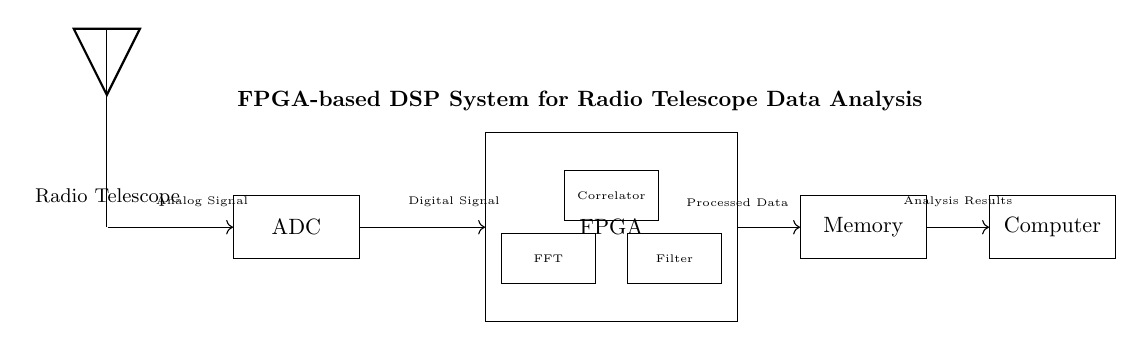What is the first component in the circuit? The first component is the Radio Telescope, which is indicated on the left side of the diagram.
Answer: Radio Telescope What does the ADC convert? The ADC converts the analog signal received from the radio telescope into a digital signal for further processing.
Answer: Analog Signal How many DSP blocks are inside the FPGA? There are three DSP blocks inside the FPGA: FFT, Filter, and Correlator.
Answer: Three What type of system is depicted in this diagram? The diagram represents an FPGA-based digital signal processing system, as stated in the title at the top of the diagram.
Answer: FPGA-based DSP System Where does the processed data go next? The processed data from the FPGA is sent to the Memory component, as shown by the arrow in the diagram.
Answer: Memory What is the final output of the system? The final output of the system is the Analysis Results, which is labeled next to the Computer component on the far right.
Answer: Analysis Results What is the function of the FPGA in this circuit? The FPGA functions as the central processing unit for managing digital signal processing tasks, including FFT, filtering, and correlation.
Answer: Digital Signal Processing 